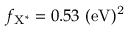<formula> <loc_0><loc_0><loc_500><loc_500>f _ { { X ^ { * } } } = 0 . 5 3 { ( e V ) ^ { 2 } }</formula> 